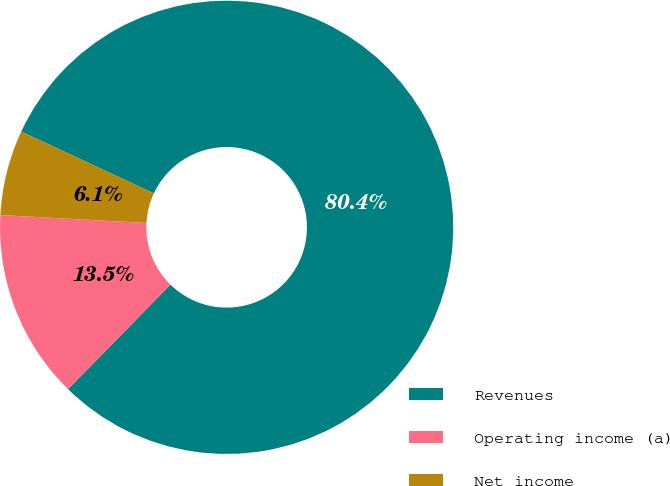Convert chart to OTSL. <chart><loc_0><loc_0><loc_500><loc_500><pie_chart><fcel>Revenues<fcel>Operating income (a)<fcel>Net income<nl><fcel>80.4%<fcel>13.52%<fcel>6.08%<nl></chart> 